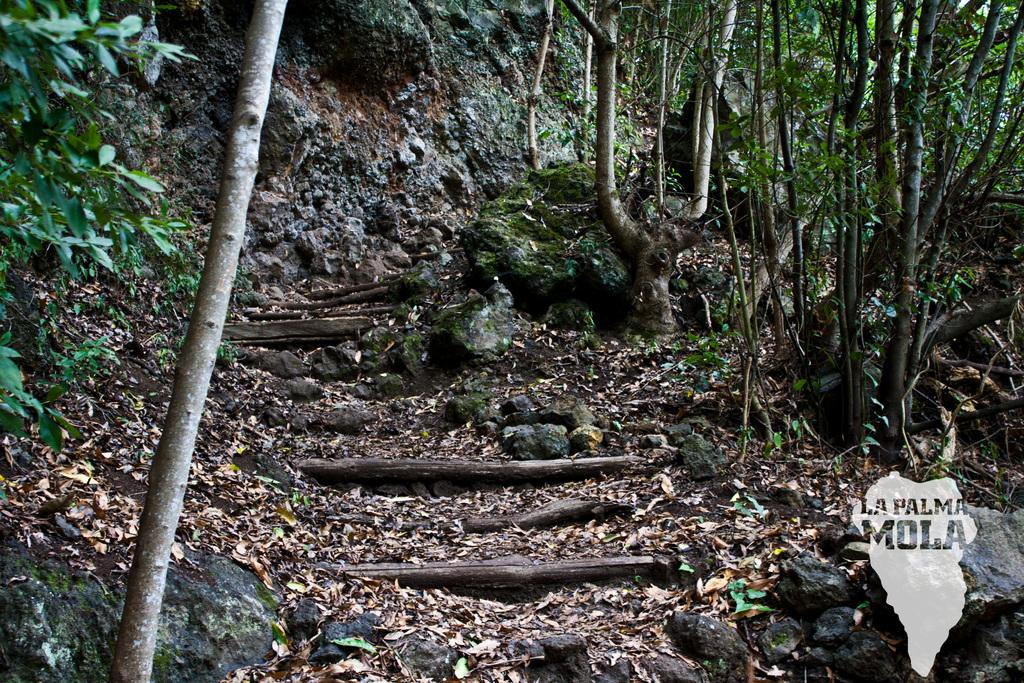What type of environment is depicted in the image? The image is taken in a forest. What are the main features of the forest? There are trees, rocks, leafs, and sticks visible on the ground in the image. What type of root can be seen growing out of the unit in the image? There is no unit or root present in the image; it is a forest scene with trees, rocks, leafs, and sticks on the ground. 